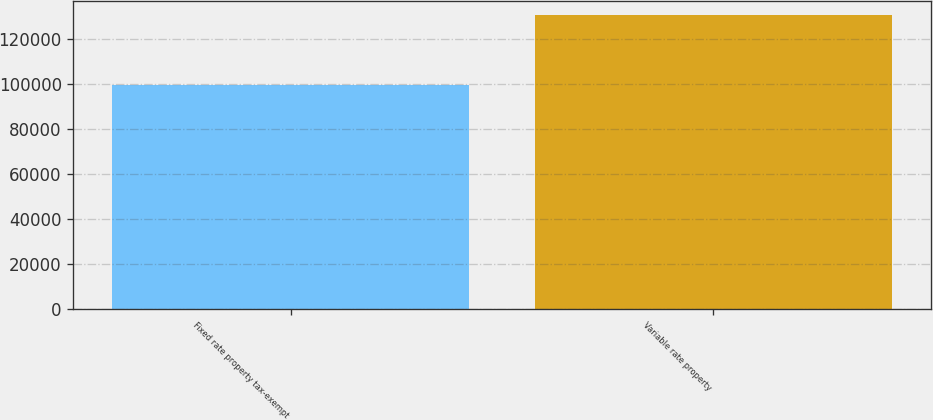Convert chart. <chart><loc_0><loc_0><loc_500><loc_500><bar_chart><fcel>Fixed rate property tax-exempt<fcel>Variable rate property<nl><fcel>99447<fcel>130599<nl></chart> 